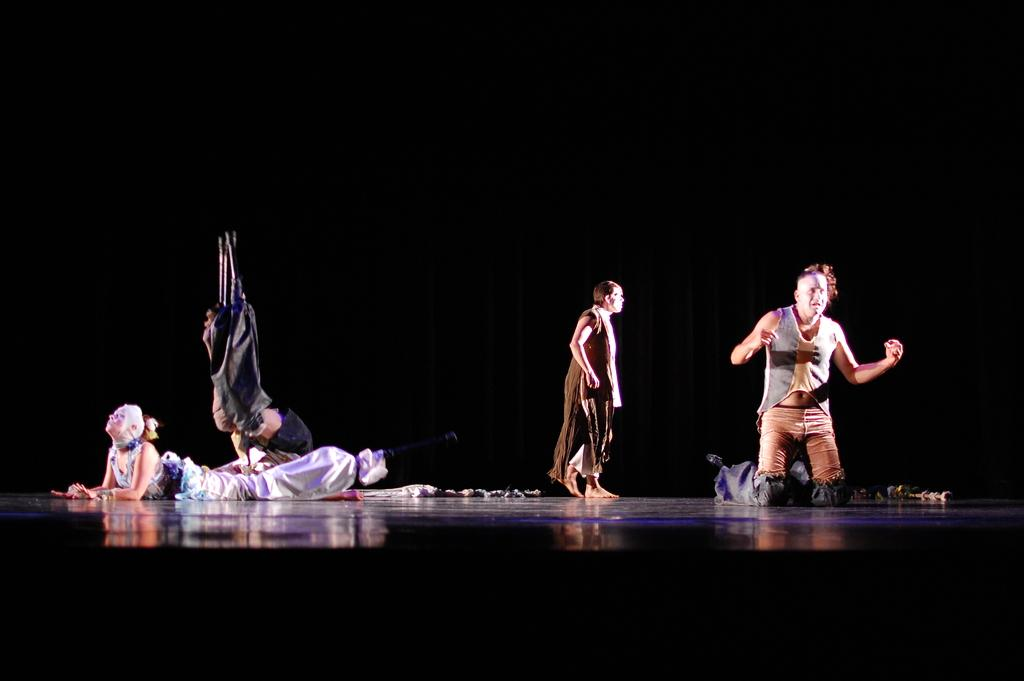How many people are in the image? There are people in the image. What are the people doing in the image? One person is walking, and one person is lying on the floor. What else can be seen in the image besides the people? There are objects in the image. Can you describe the background of the image? The background of the image is dark. What type of yam is being used to create an account in the image? There is no yam or account creation activity present in the image. Can you tell me how many carts are visible in the image? There are no carts visible in the image. 